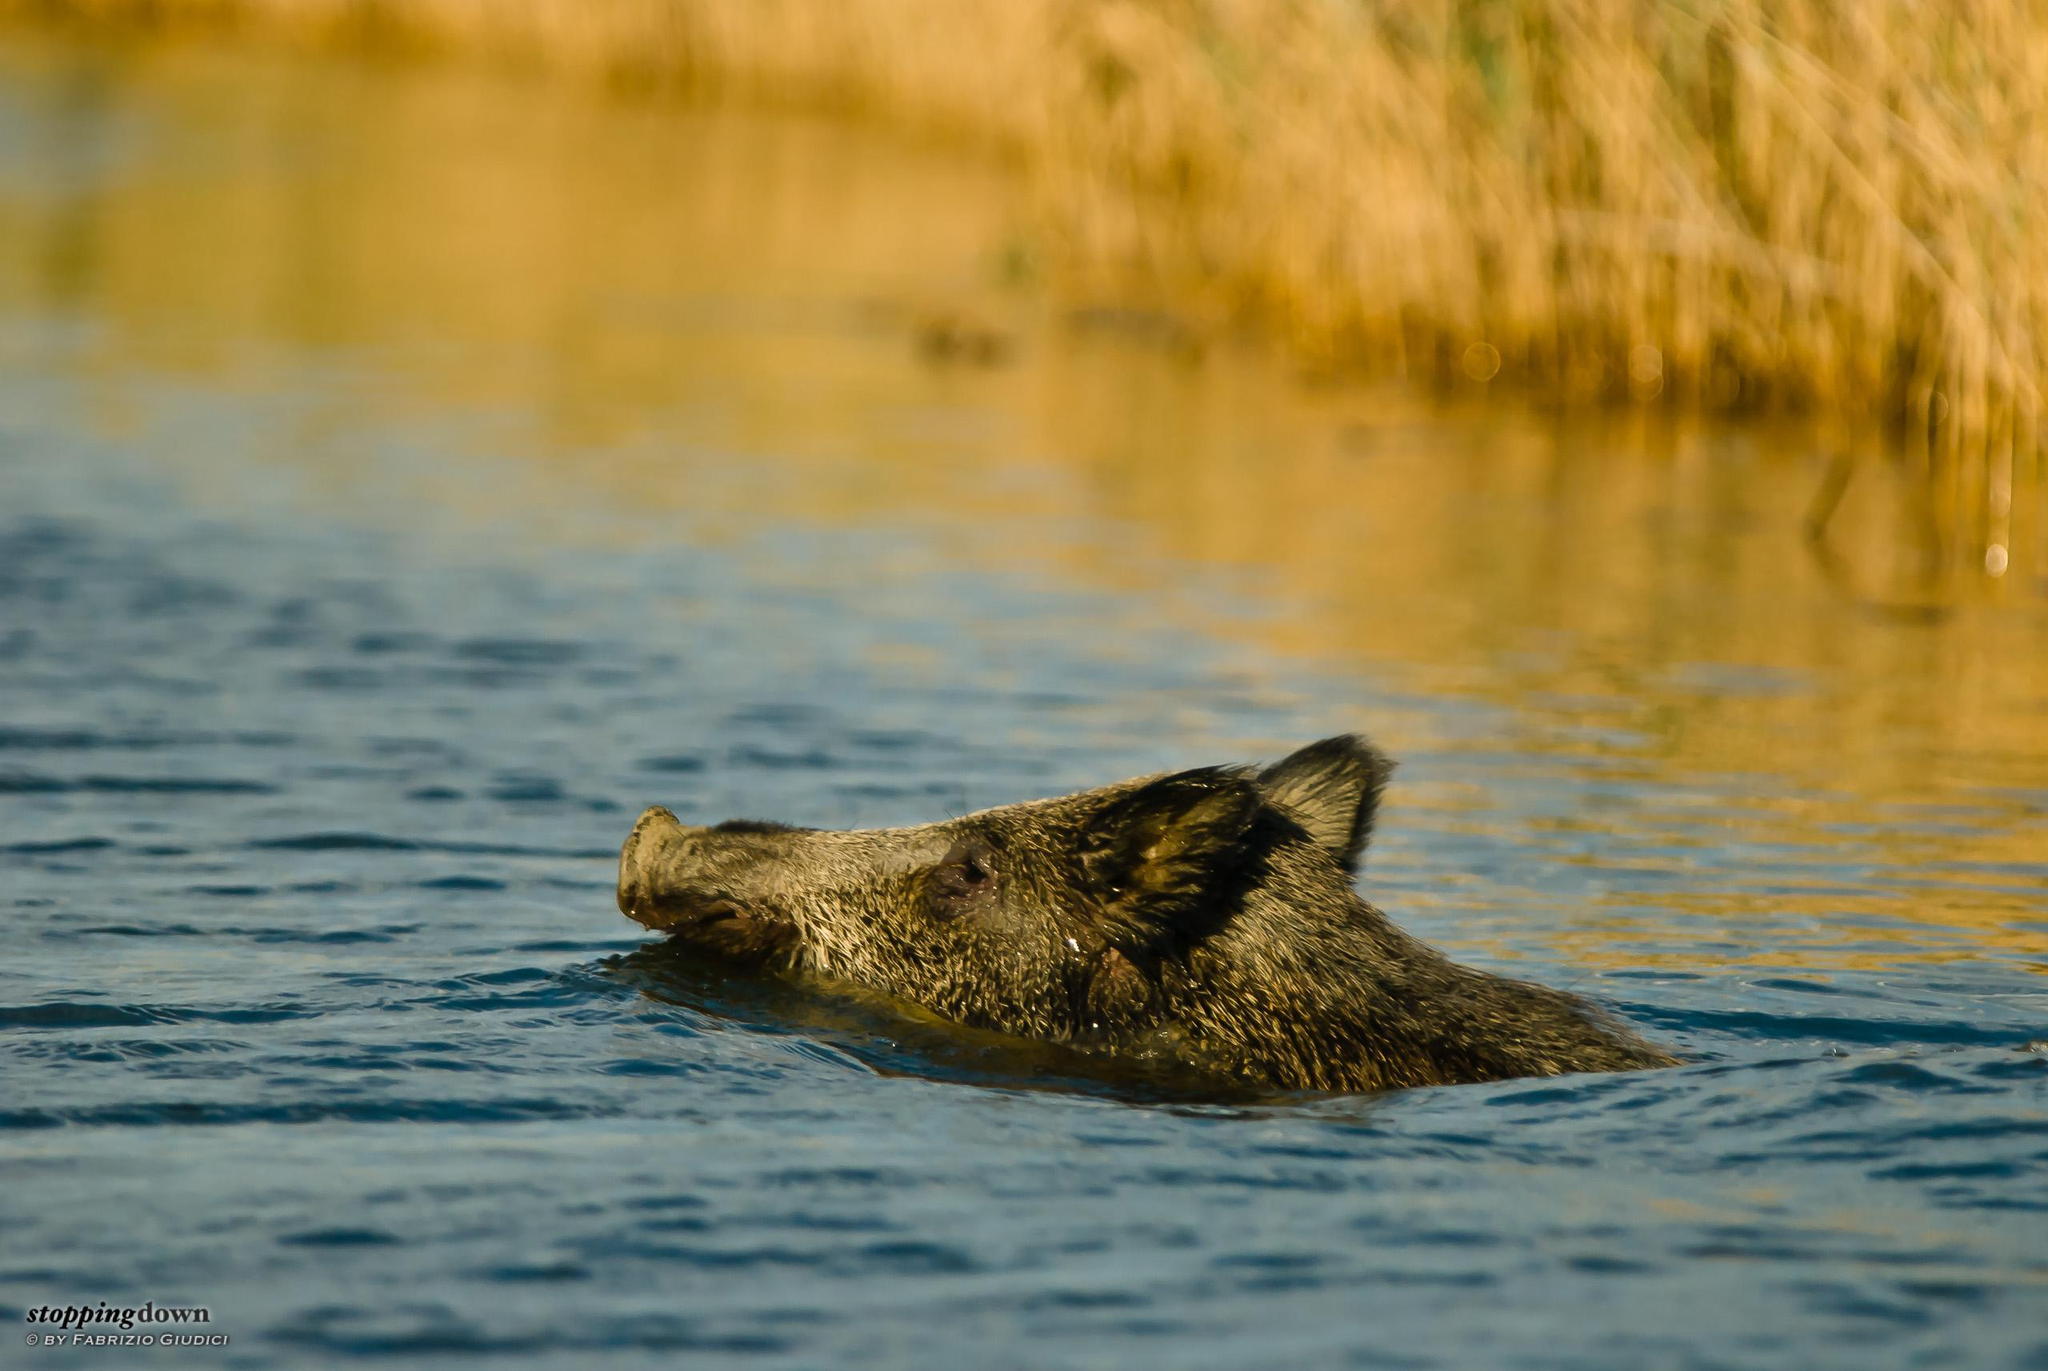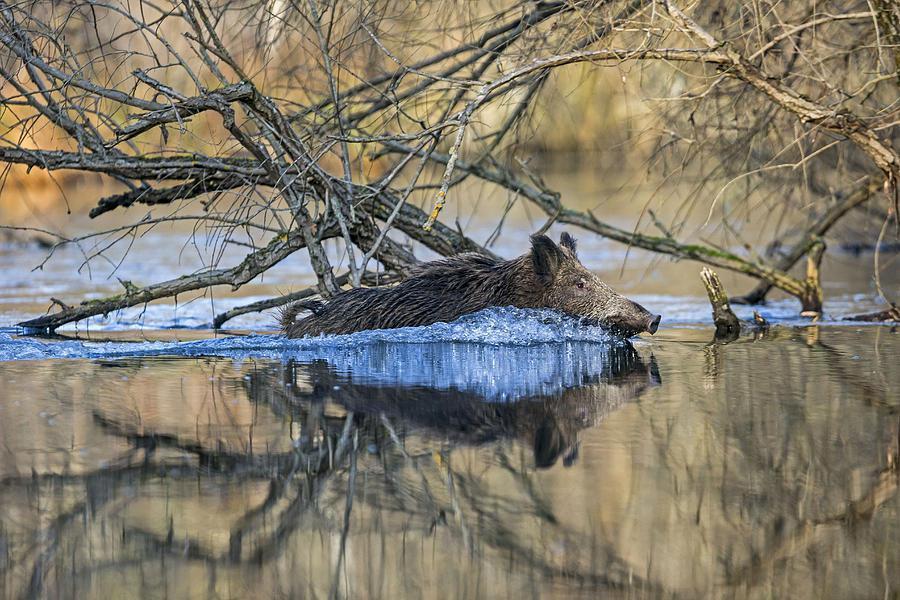The first image is the image on the left, the second image is the image on the right. Analyze the images presented: Is the assertion "The left image contains one wild pig swimming leftward, with tall grass on the water's edge behind him." valid? Answer yes or no. Yes. The first image is the image on the left, the second image is the image on the right. Assess this claim about the two images: "In the image on the left there is one boar swimming in the water.". Correct or not? Answer yes or no. Yes. 